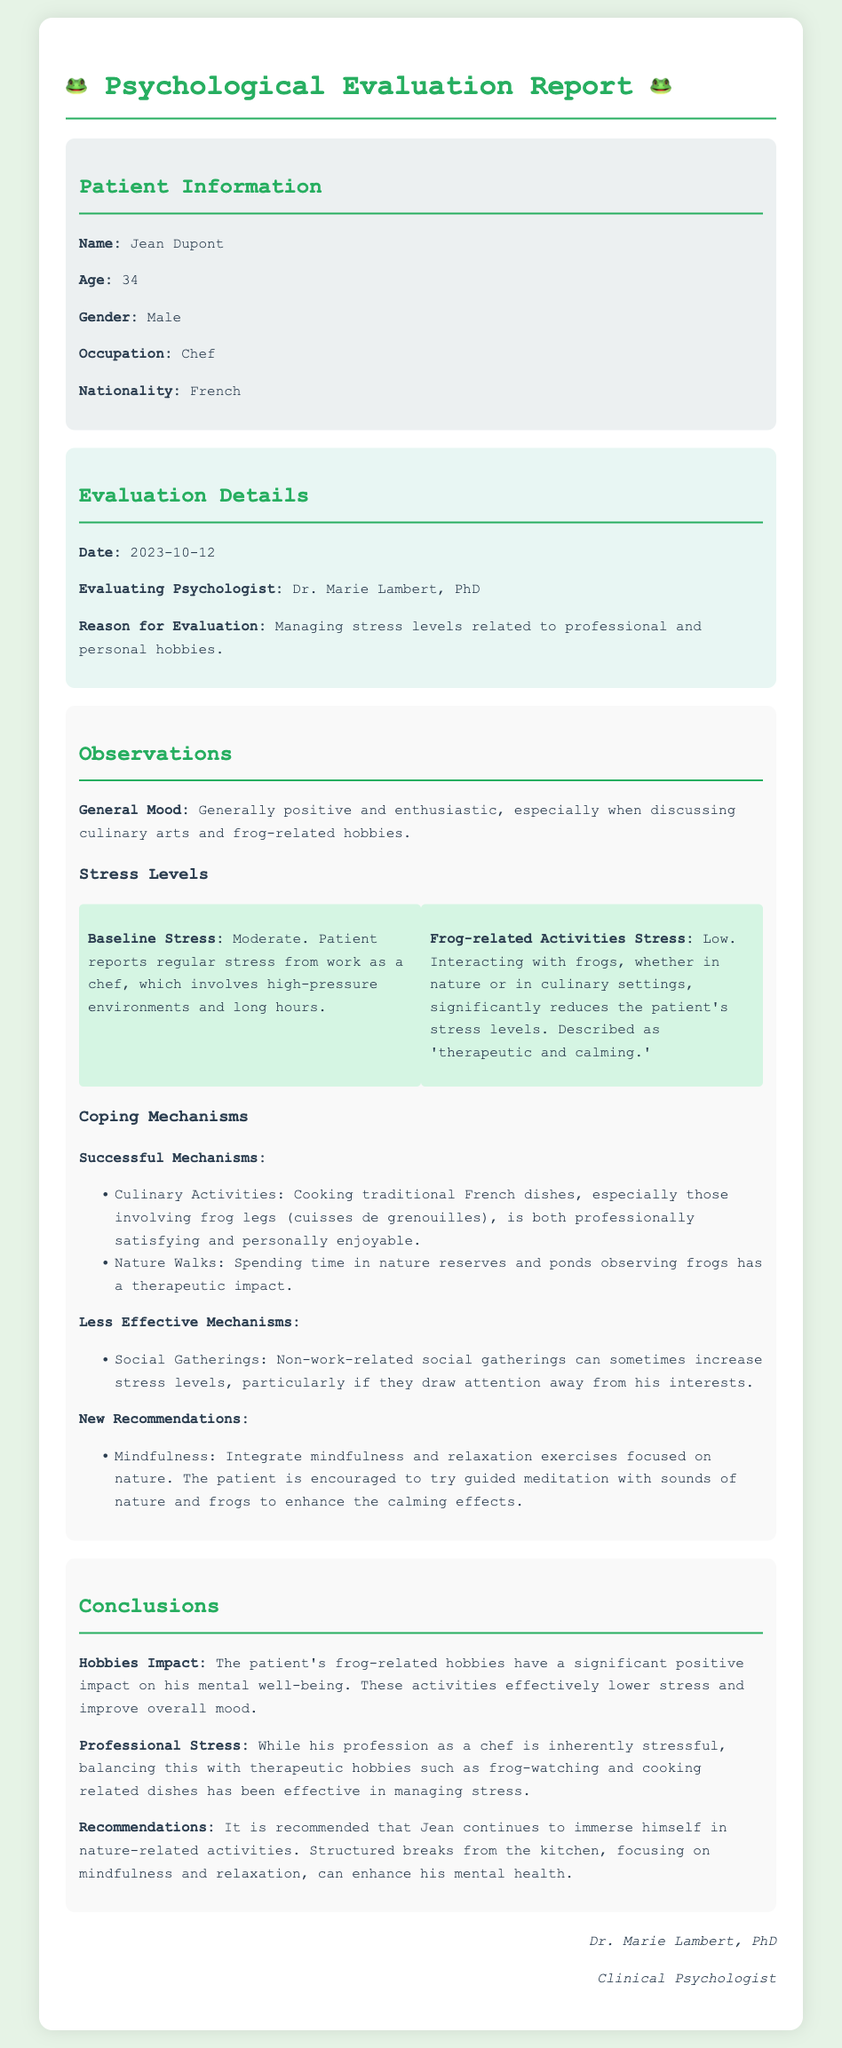what is the name of the patient? The document states the patient's name as Jean Dupont.
Answer: Jean Dupont what is the age of the patient? The document indicates the patient's age is 34 years.
Answer: 34 who conducted the psychological evaluation? The evaluating psychologist mentioned in the document is Dr. Marie Lambert.
Answer: Dr. Marie Lambert what was the date of the evaluation? The evaluation was conducted on the date mentioned in the document, which is October 12, 2023.
Answer: 2023-10-12 what is the baseline stress level reported by the patient? The document states that the patient's baseline stress level is moderate.
Answer: Moderate how does interacting with frogs affect the patient's stress levels? According to the document, interacting with frogs significantly reduces the patient's stress levels, described as 'therapeutic and calming.'
Answer: Low what hobby has a therapeutic impact on the patient? The document mentions that spending time observing frogs has a therapeutic impact on the patient.
Answer: Nature Walks what is one of the less effective coping mechanisms for the patient? The document states that non-work-related social gatherings can increase stress levels.
Answer: Social Gatherings what is one recommendation given to the patient? The document recommends integrating mindfulness and relaxation exercises focused on nature.
Answer: Mindfulness 